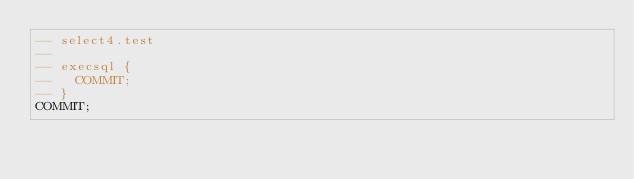Convert code to text. <code><loc_0><loc_0><loc_500><loc_500><_SQL_>-- select4.test
-- 
-- execsql {
--   COMMIT;
-- }
COMMIT;</code> 